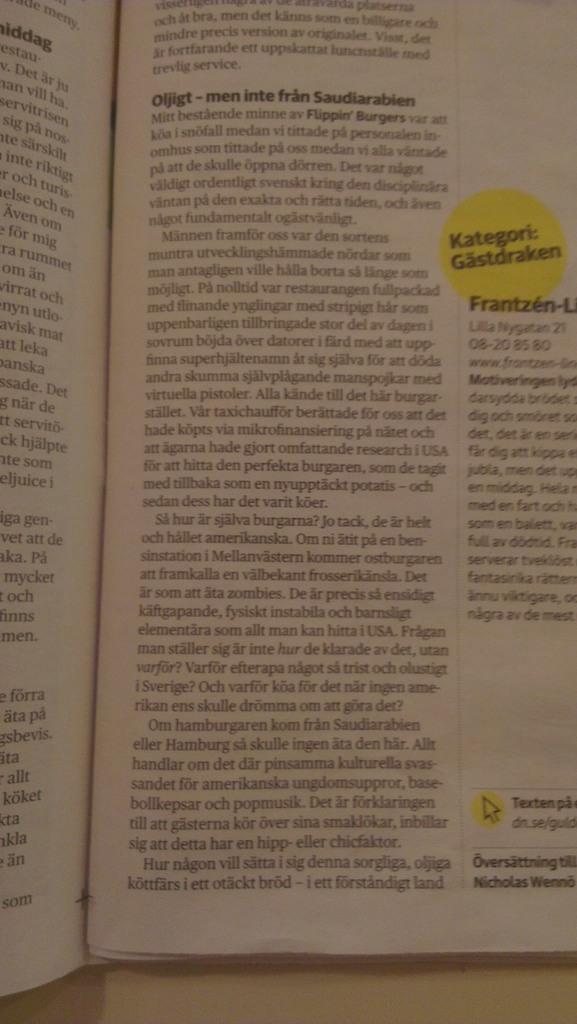What is in the yellow bubble?
Give a very brief answer. Kategori: gastdraken. 